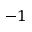Convert formula to latex. <formula><loc_0><loc_0><loc_500><loc_500>- 1</formula> 